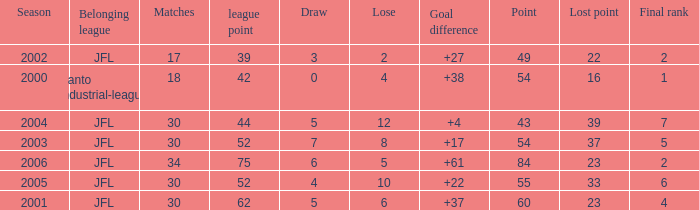Tell me the highest point with lost point being 33 and league point less than 52 None. 